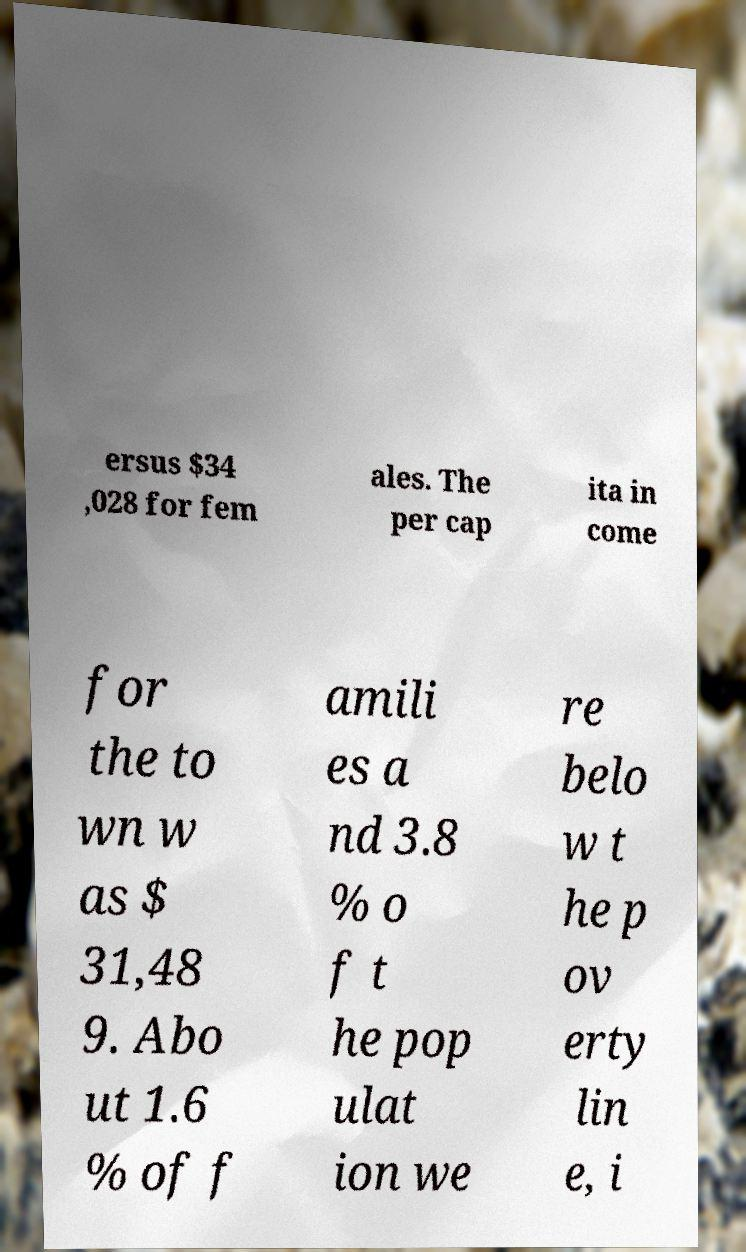What messages or text are displayed in this image? I need them in a readable, typed format. ersus $34 ,028 for fem ales. The per cap ita in come for the to wn w as $ 31,48 9. Abo ut 1.6 % of f amili es a nd 3.8 % o f t he pop ulat ion we re belo w t he p ov erty lin e, i 